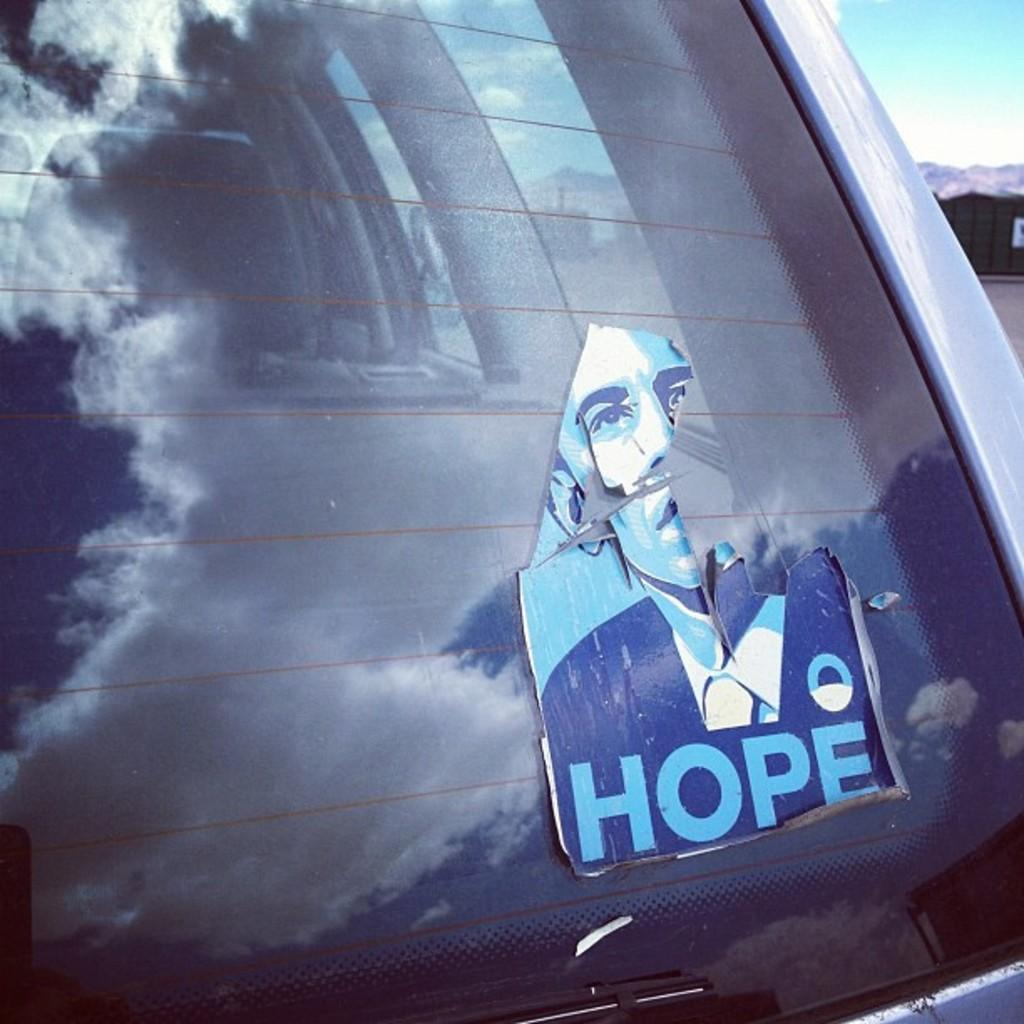What part of a car is visible in the image? The back windshield of a car is visible in the image. What is attached to the windshield of the car? There is a photo stuck on the windshield of the car. What can be seen in the background of the image? The sky is visible in the background of the image. What nation is represented by the team in the image? There is no team or nation represented in the image; it only features the back windshield of a car with a photo stuck on it. 